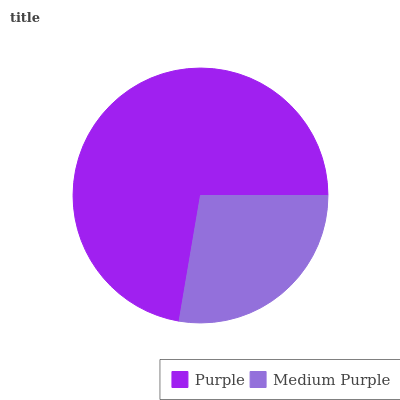Is Medium Purple the minimum?
Answer yes or no. Yes. Is Purple the maximum?
Answer yes or no. Yes. Is Medium Purple the maximum?
Answer yes or no. No. Is Purple greater than Medium Purple?
Answer yes or no. Yes. Is Medium Purple less than Purple?
Answer yes or no. Yes. Is Medium Purple greater than Purple?
Answer yes or no. No. Is Purple less than Medium Purple?
Answer yes or no. No. Is Purple the high median?
Answer yes or no. Yes. Is Medium Purple the low median?
Answer yes or no. Yes. Is Medium Purple the high median?
Answer yes or no. No. Is Purple the low median?
Answer yes or no. No. 